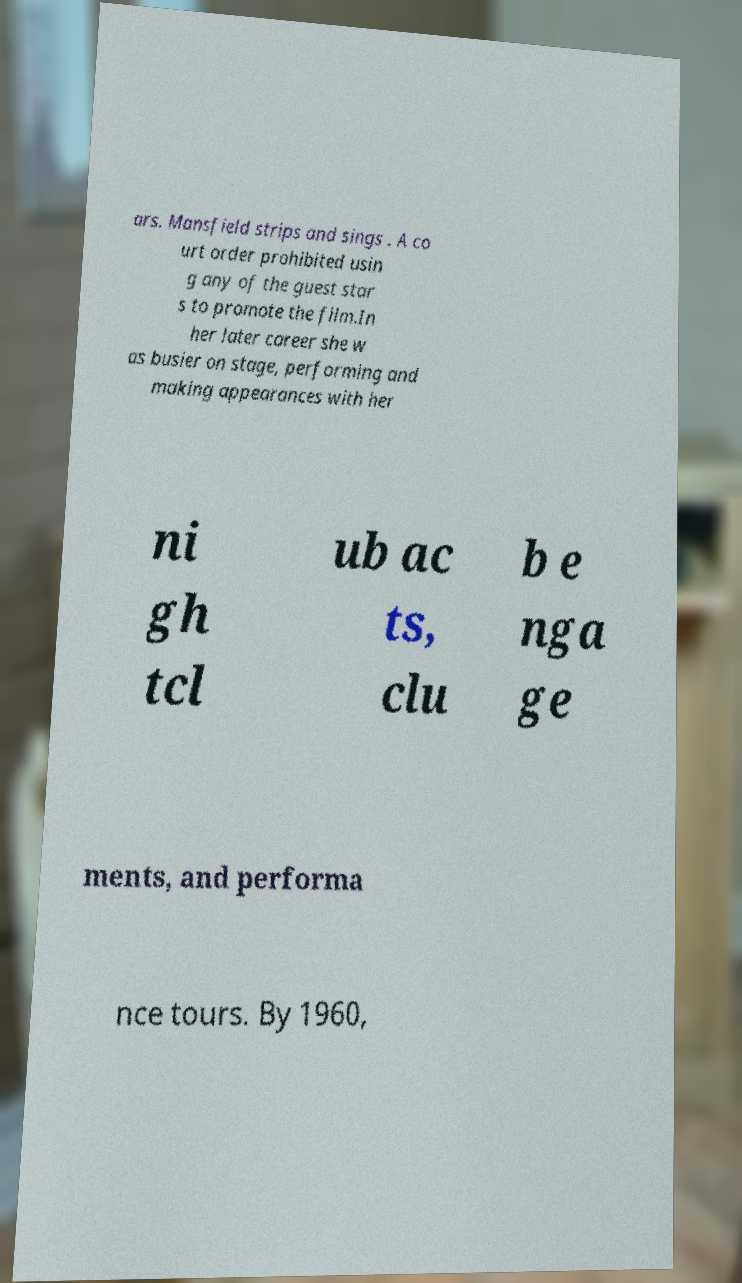Please read and relay the text visible in this image. What does it say? ars. Mansfield strips and sings . A co urt order prohibited usin g any of the guest star s to promote the film.In her later career she w as busier on stage, performing and making appearances with her ni gh tcl ub ac ts, clu b e nga ge ments, and performa nce tours. By 1960, 